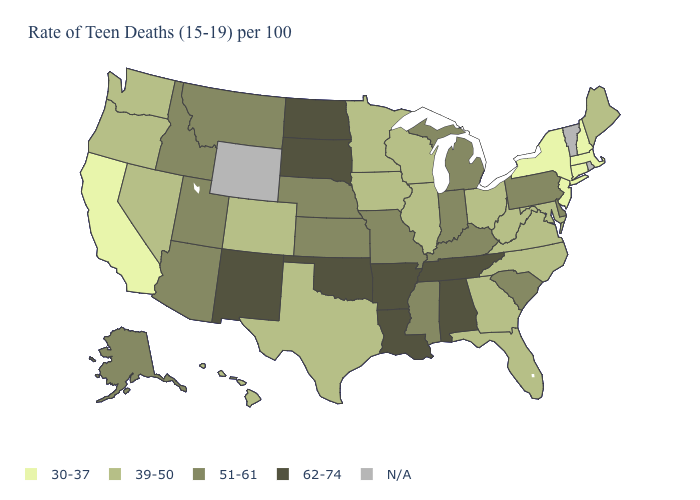What is the lowest value in the USA?
Be succinct. 30-37. What is the value of New York?
Short answer required. 30-37. What is the value of Indiana?
Keep it brief. 51-61. What is the value of Vermont?
Quick response, please. N/A. What is the value of Indiana?
Keep it brief. 51-61. Which states have the highest value in the USA?
Answer briefly. Alabama, Arkansas, Louisiana, New Mexico, North Dakota, Oklahoma, South Dakota, Tennessee. Name the states that have a value in the range 39-50?
Answer briefly. Colorado, Florida, Georgia, Hawaii, Illinois, Iowa, Maine, Maryland, Minnesota, Nevada, North Carolina, Ohio, Oregon, Texas, Virginia, Washington, West Virginia, Wisconsin. Does North Dakota have the highest value in the USA?
Be succinct. Yes. Among the states that border Arkansas , which have the highest value?
Concise answer only. Louisiana, Oklahoma, Tennessee. Which states have the highest value in the USA?
Short answer required. Alabama, Arkansas, Louisiana, New Mexico, North Dakota, Oklahoma, South Dakota, Tennessee. What is the lowest value in states that border Michigan?
Write a very short answer. 39-50. Which states have the lowest value in the Northeast?
Be succinct. Connecticut, Massachusetts, New Hampshire, New Jersey, New York. What is the lowest value in states that border Virginia?
Be succinct. 39-50. 